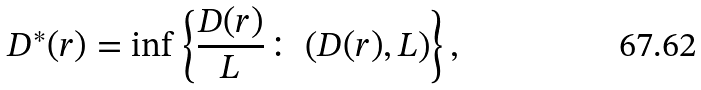Convert formula to latex. <formula><loc_0><loc_0><loc_500><loc_500>D ^ { * } ( r ) = \inf \left \{ \frac { D ( r ) } { L } \colon \left ( D ( r ) , L \right ) \right \} ,</formula> 